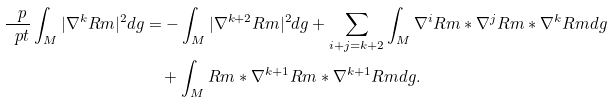Convert formula to latex. <formula><loc_0><loc_0><loc_500><loc_500>\frac { \ p } { \ p t } \int _ { M } | \nabla ^ { k } R m | ^ { 2 } d g & = - \int _ { M } | \nabla ^ { k + 2 } R m | ^ { 2 } d g + \sum _ { i + j = k + 2 } \int _ { M } \nabla ^ { i } R m * \nabla ^ { j } R m * \nabla ^ { k } R m d g \\ & \quad + \int _ { M } R m * \nabla ^ { k + 1 } R m * \nabla ^ { k + 1 } R m d g .</formula> 